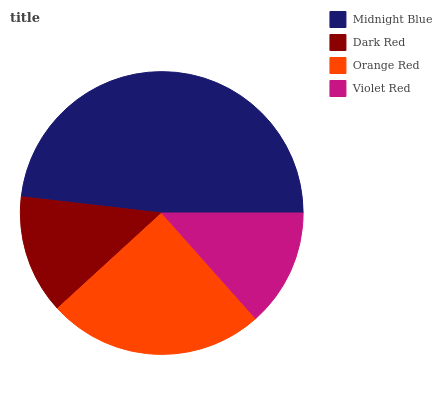Is Violet Red the minimum?
Answer yes or no. Yes. Is Midnight Blue the maximum?
Answer yes or no. Yes. Is Dark Red the minimum?
Answer yes or no. No. Is Dark Red the maximum?
Answer yes or no. No. Is Midnight Blue greater than Dark Red?
Answer yes or no. Yes. Is Dark Red less than Midnight Blue?
Answer yes or no. Yes. Is Dark Red greater than Midnight Blue?
Answer yes or no. No. Is Midnight Blue less than Dark Red?
Answer yes or no. No. Is Orange Red the high median?
Answer yes or no. Yes. Is Dark Red the low median?
Answer yes or no. Yes. Is Dark Red the high median?
Answer yes or no. No. Is Violet Red the low median?
Answer yes or no. No. 